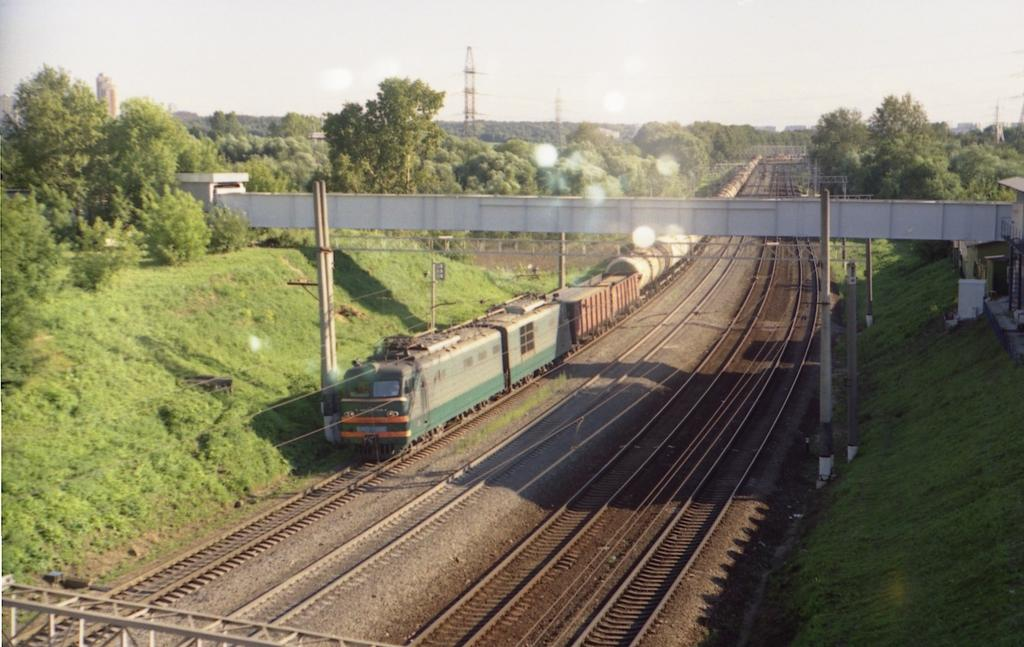What type of view is provided in the image? The image is a top view. What is moving on the railway track in the image? There is a train moving on the railway track in the image. What is the board used for in the image? The purpose of the board in the image is not specified, but it could be a sign or a platform. What are the poles used for in the image? The poles in the image could be used for supporting electrical wires, signage, or other infrastructure. What type of vegetation is present in the image? There are trees in the image. What tall structures are visible in the image? There are towers in the image. What is visible in the background of the image? The sky is visible in the background of the image. Can you see any water in the image? There is no water visible in the image. What type of request is being made by the train in the image? There is no indication of a request being made by the train in the image, as trains do not have the ability to make requests. 